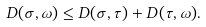<formula> <loc_0><loc_0><loc_500><loc_500>D ( \sigma , \omega ) \leq D ( \sigma , \tau ) + D ( \tau , \omega ) .</formula> 